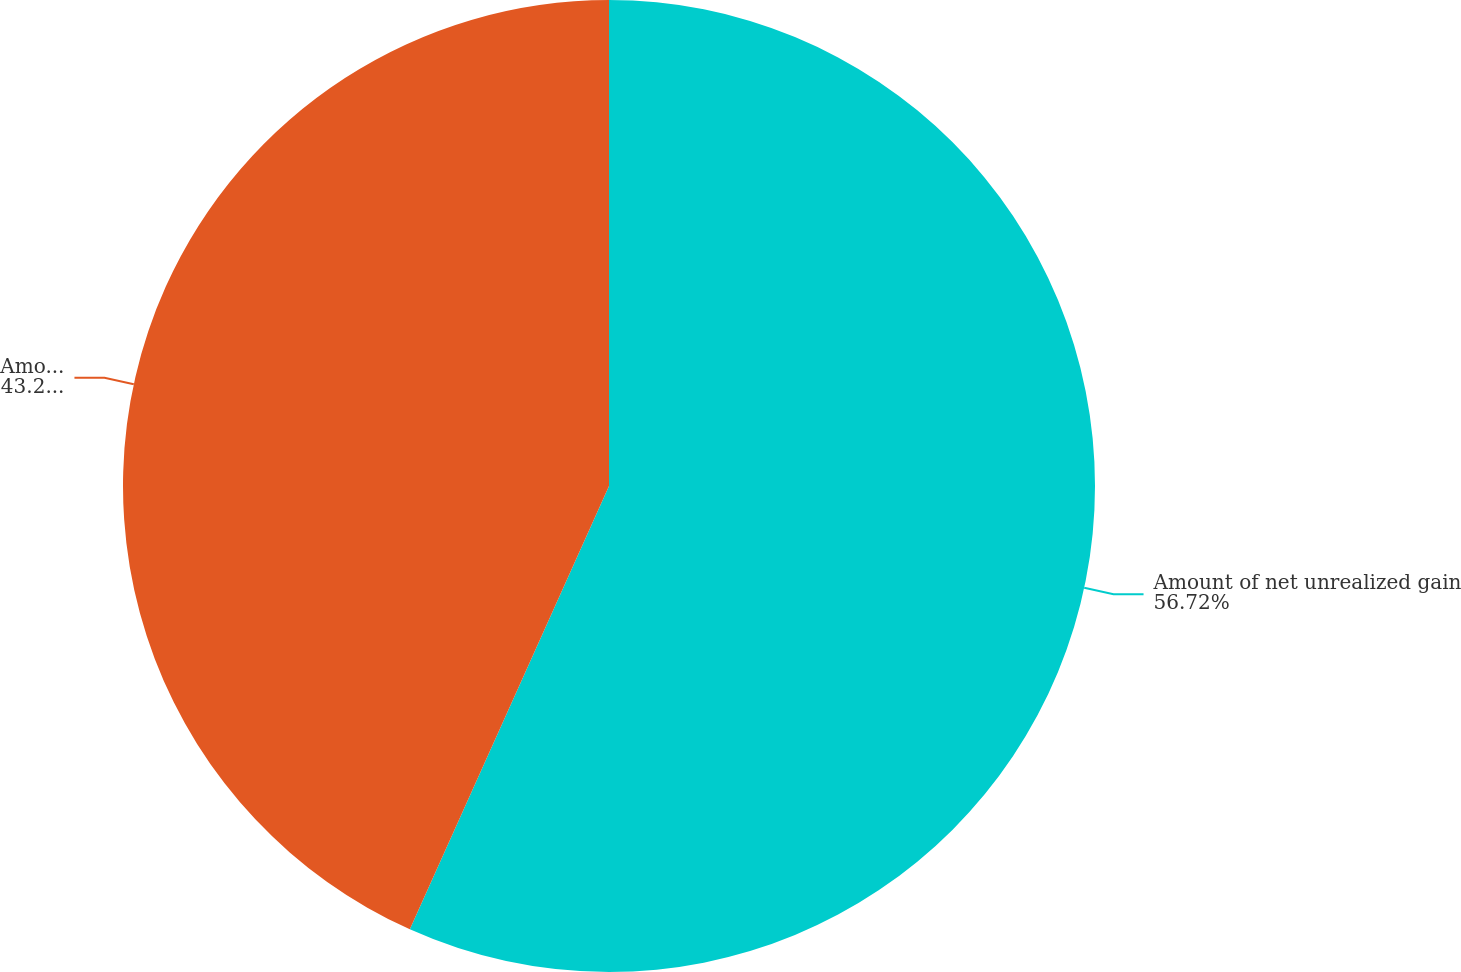Convert chart to OTSL. <chart><loc_0><loc_0><loc_500><loc_500><pie_chart><fcel>Amount of net unrealized gain<fcel>Amount of net losses<nl><fcel>56.72%<fcel>43.28%<nl></chart> 